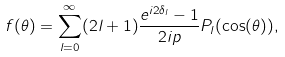<formula> <loc_0><loc_0><loc_500><loc_500>f ( \theta ) = \sum _ { l = 0 } ^ { \infty } ( 2 l + 1 ) \frac { e ^ { i 2 \delta _ { l } } - 1 } { 2 i p } P _ { l } ( \cos ( \theta ) ) ,</formula> 